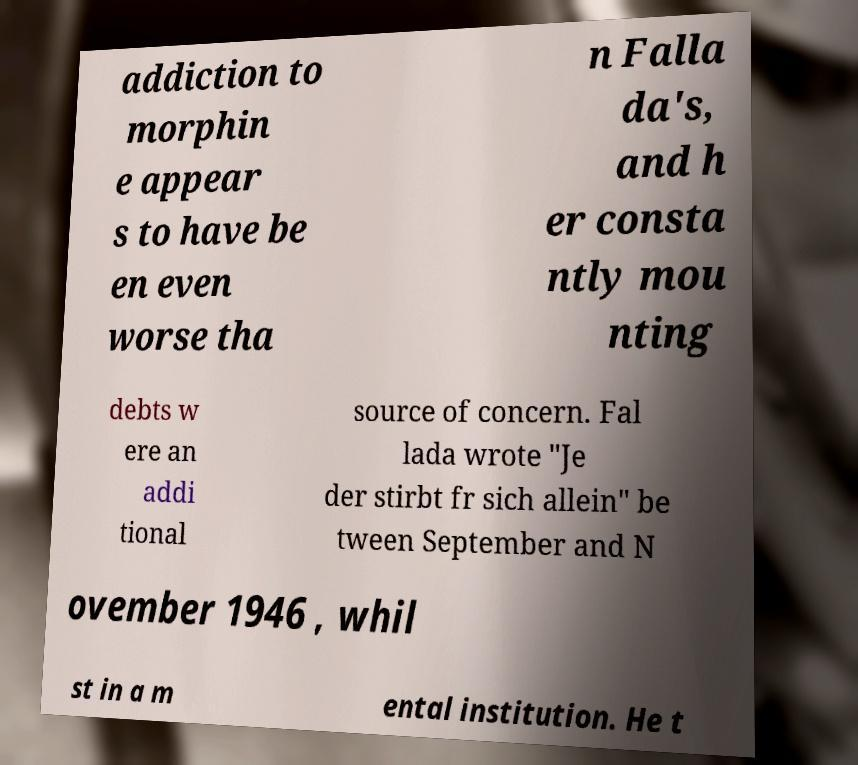There's text embedded in this image that I need extracted. Can you transcribe it verbatim? addiction to morphin e appear s to have be en even worse tha n Falla da's, and h er consta ntly mou nting debts w ere an addi tional source of concern. Fal lada wrote "Je der stirbt fr sich allein" be tween September and N ovember 1946 , whil st in a m ental institution. He t 